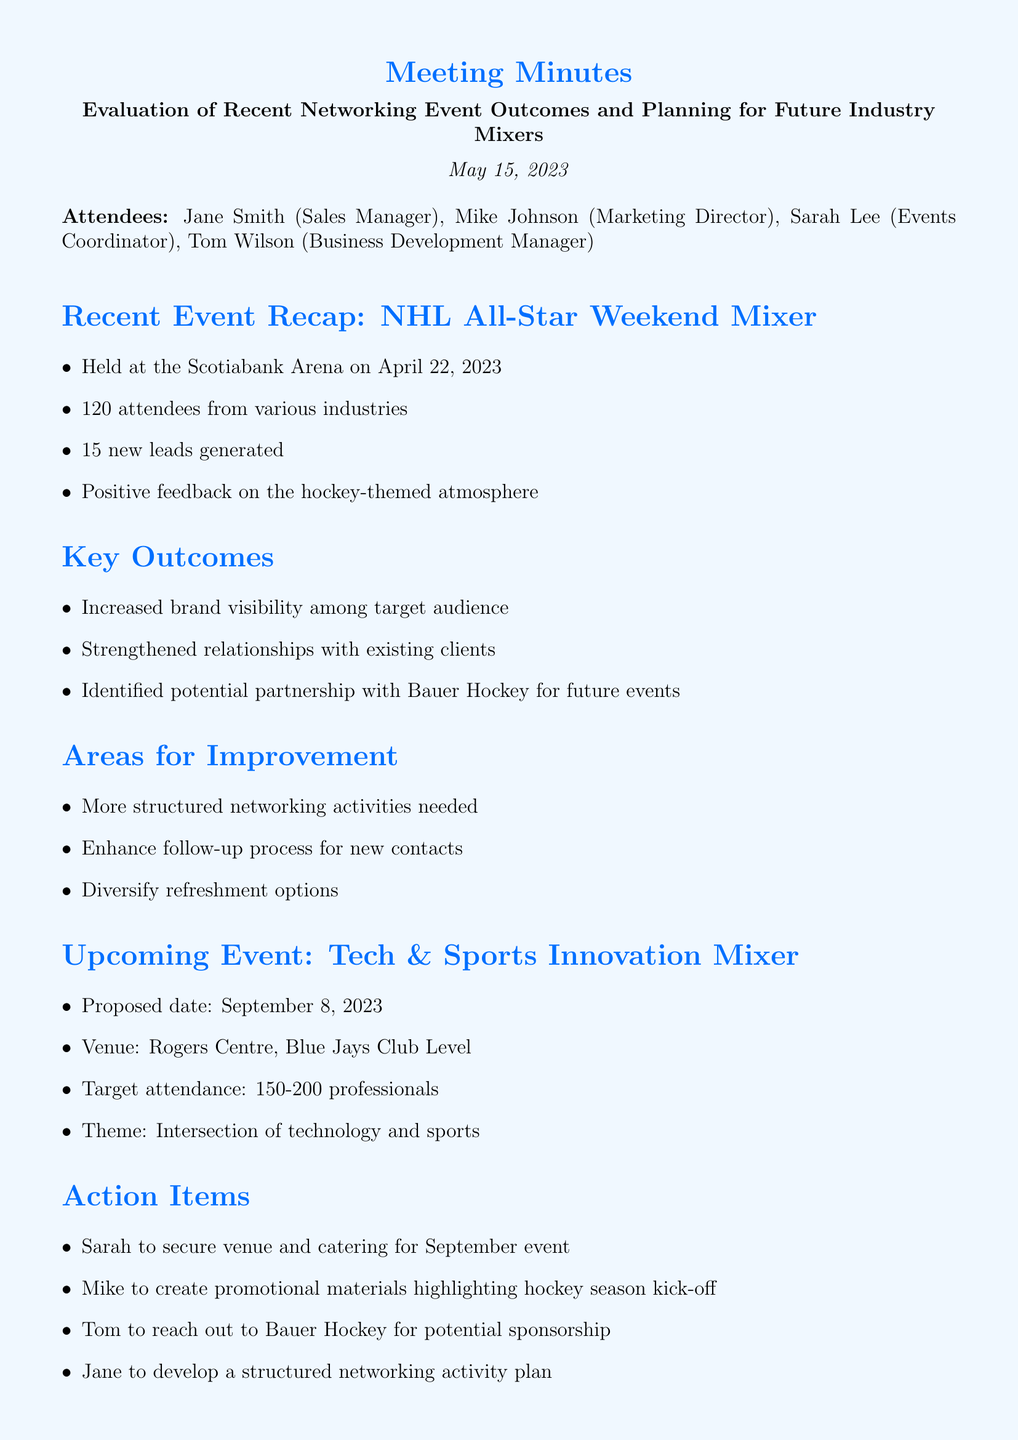What was the date of the recent NHL All-Star Weekend Mixer? The document states that the NHL All-Star Weekend Mixer was held on April 22, 2023.
Answer: April 22, 2023 How many attendees were present at the recent event? According to the document, there were 120 attendees from various industries.
Answer: 120 attendees What is the proposed date for the upcoming Tech & Sports Innovation Mixer? The document mentions the proposed date for the upcoming event is September 8, 2023.
Answer: September 8, 2023 What was identified as a potential partnership for future events? The document highlights Bauer Hockey as a potential partnership for future events.
Answer: Bauer Hockey What are the target attendance numbers for the next event? The document indicates a target attendance of 150-200 professionals for the upcoming event.
Answer: 150-200 professionals What is one area for improvement mentioned after the recent networking event? The document lists several areas for improvement, one being the need for more structured networking activities.
Answer: More structured networking activities Who is responsible for securing the venue and catering for the September event? The document states that Sarah is tasked with securing the venue and catering for the upcoming event.
Answer: Sarah What aspect of the follow-up process needs enhancement? The document mentions that the follow-up process for new contacts needs to be enhanced.
Answer: Enhance follow-up process When is the next meeting scheduled? The document specifies that the next meeting is scheduled for June 5, 2023.
Answer: June 5, 2023 